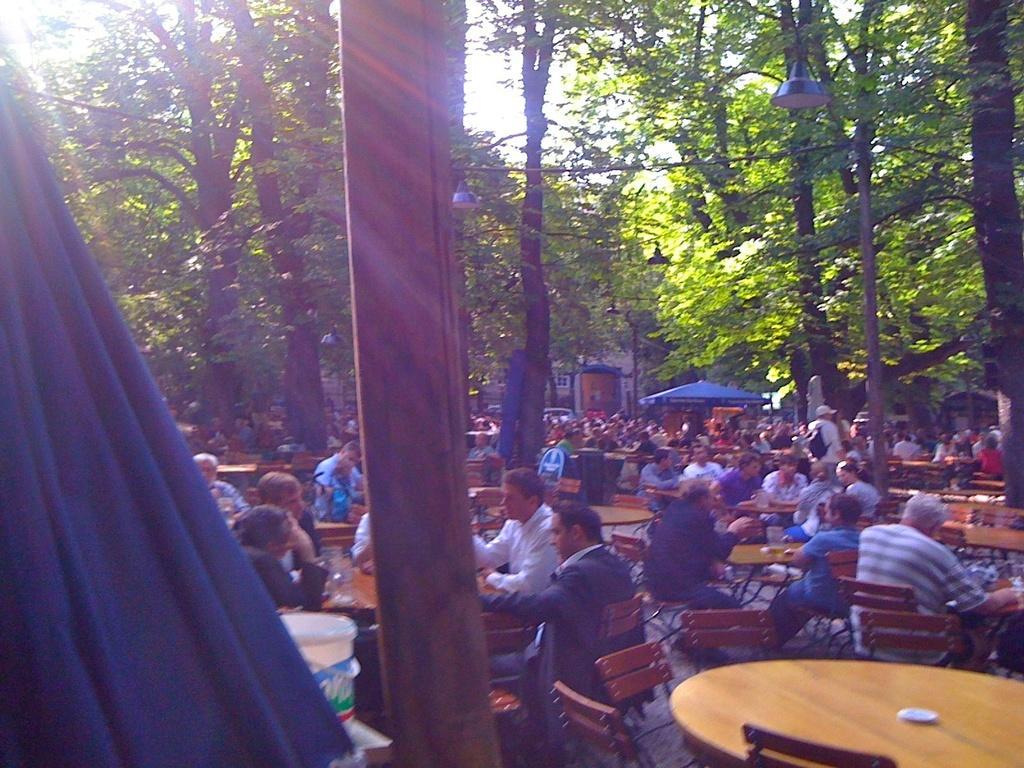Describe this image in one or two sentences. In the image I can see some people sitting on the chairs around the tables on which there are some things and around there are some trees and tents. 